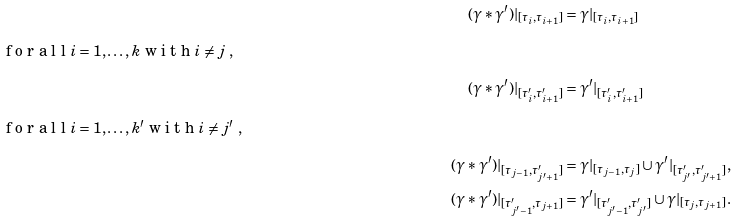<formula> <loc_0><loc_0><loc_500><loc_500>( \gamma * \gamma ^ { \prime } ) | _ { [ \tau _ { i } , \tau _ { i + 1 } ] } & = \gamma | _ { [ \tau _ { i } , \tau _ { i + 1 } ] } \\ \intertext { f o r a l l $ i = 1 , \dots , k $ w i t h $ i \neq j $ , } ( \gamma * \gamma ^ { \prime } ) | _ { [ \tau _ { i } ^ { \prime } , \tau _ { i + 1 } ^ { \prime } ] } & = \gamma ^ { \prime } | _ { [ \tau _ { i } ^ { \prime } , \tau _ { i + 1 } ^ { \prime } ] } \\ \intertext { f o r a l l $ i = 1 , \dots , k ^ { \prime } $ w i t h $ i \neq j ^ { \prime } $ , } ( \gamma * \gamma ^ { \prime } ) | _ { [ \tau _ { j - 1 } , \tau _ { j ^ { \prime } + 1 } ^ { \prime } ] } & = \gamma | _ { [ \tau _ { j - 1 } , \tau _ { j } ] } \cup \gamma ^ { \prime } | _ { [ \tau _ { j ^ { \prime } } ^ { \prime } , \tau _ { j ^ { \prime } + 1 } ^ { \prime } ] } , \\ ( \gamma * \gamma ^ { \prime } ) | _ { [ \tau _ { j ^ { \prime } - 1 } ^ { \prime } , \tau _ { j + 1 } ] } & = \gamma ^ { \prime } | _ { [ \tau _ { j ^ { \prime } - 1 } ^ { \prime } , \tau _ { j ^ { \prime } } ^ { \prime } ] } \cup \gamma | _ { [ \tau _ { j } , \tau _ { j + 1 } ] } .</formula> 